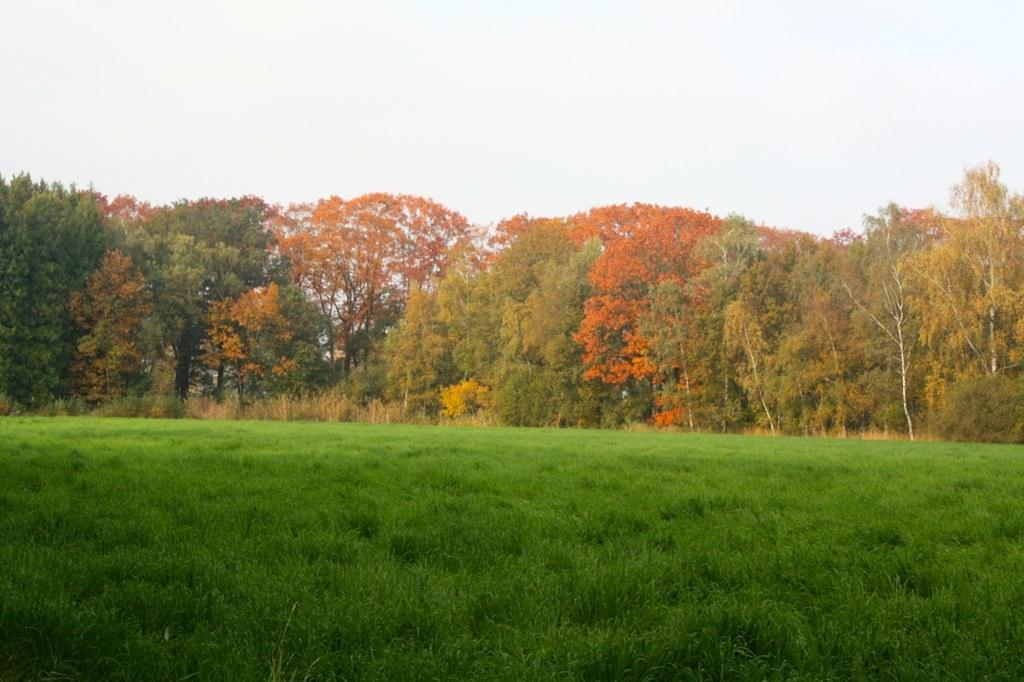What type of landscape is depicted at the bottom of the image? There is grassland at the bottom side of the image. What can be seen in the center of the image? There are trees in the center of the image. What religion is being practiced by the woman in the image? There is no woman present in the image, and therefore no religious practice can be observed. 